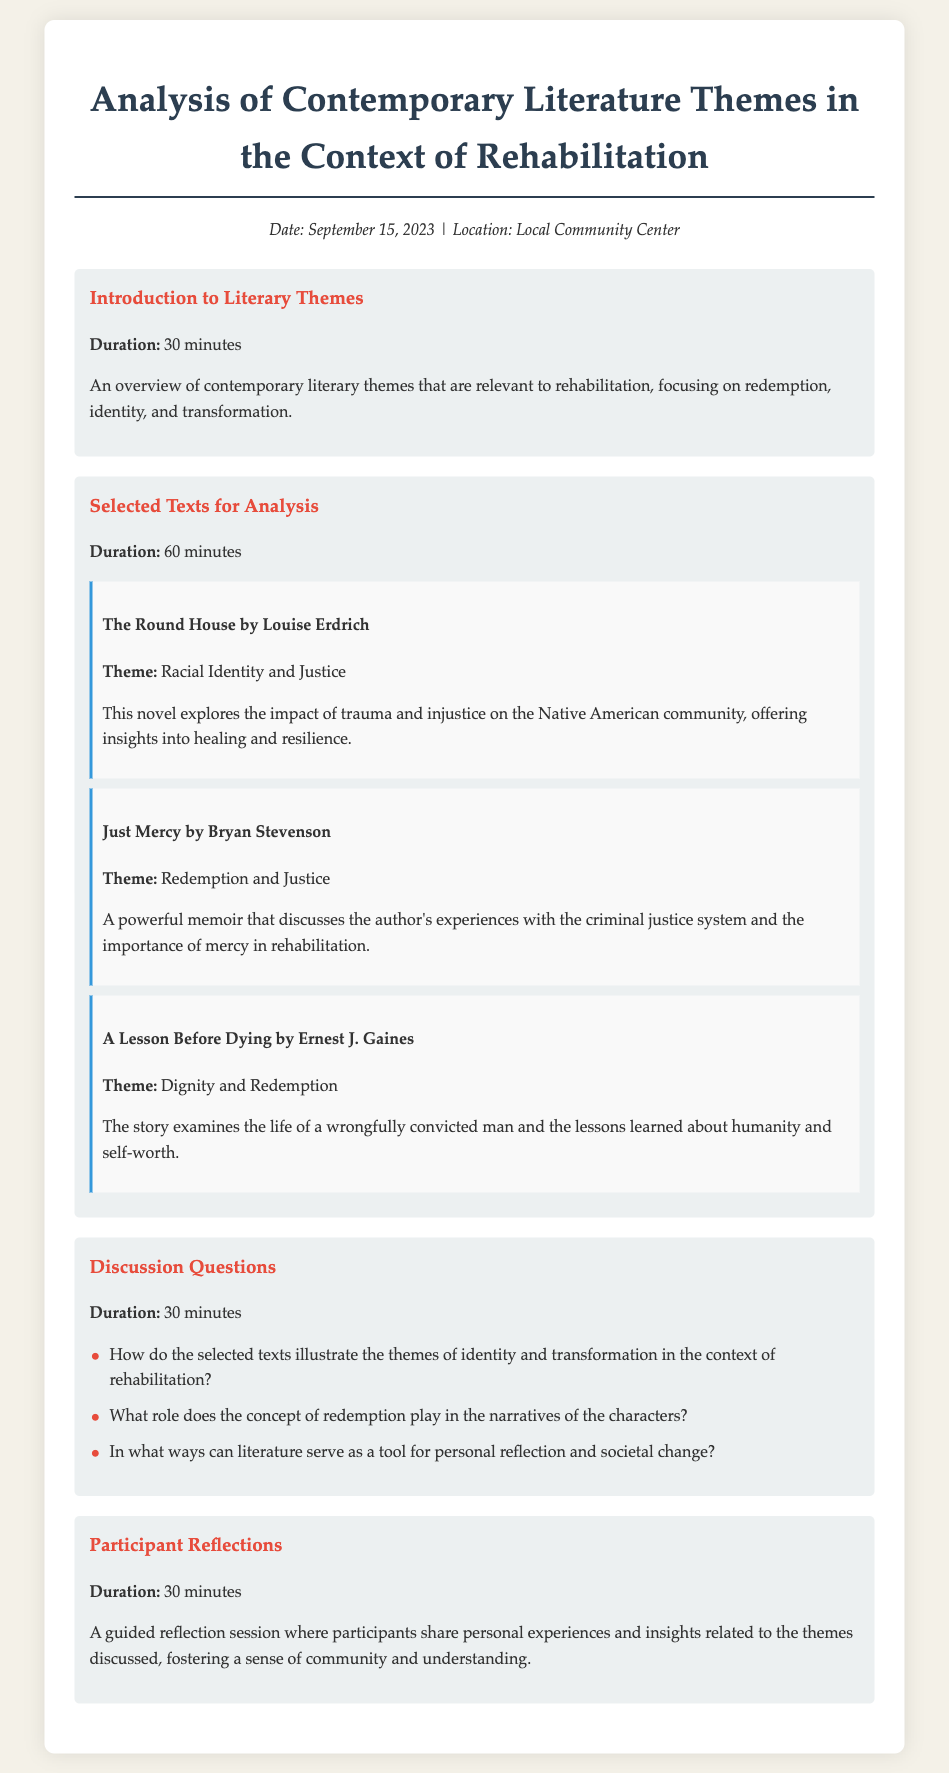What is the date of the event? The date is provided in the meta-info section of the document.
Answer: September 15, 2023 What is the location of the event? The location is mentioned in the meta-info section of the document.
Answer: Local Community Center How long is the discussion on selected texts for analysis? The duration is specified under the agenda item for selected texts.
Answer: 60 minutes Which author wrote "Just Mercy"? The author of the book is indicated under the "Selected Texts for Analysis" section.
Answer: Bryan Stevenson What theme is explored in "The Round House"? The theme is stated clearly beneath the title in the selected texts section.
Answer: Racial Identity and Justice How many discussion questions are listed? The number of questions can be counted from the discussion questions section.
Answer: Three What is the main purpose of the Participant Reflections section? The purpose is described in the participant reflections agenda item.
Answer: Share personal experiences and insights What type of literature theme is emphasized in the introduction? The specific themes that are mentioned in the introduction are relevant to rehabilitation.
Answer: Redemption, identity, and transformation 